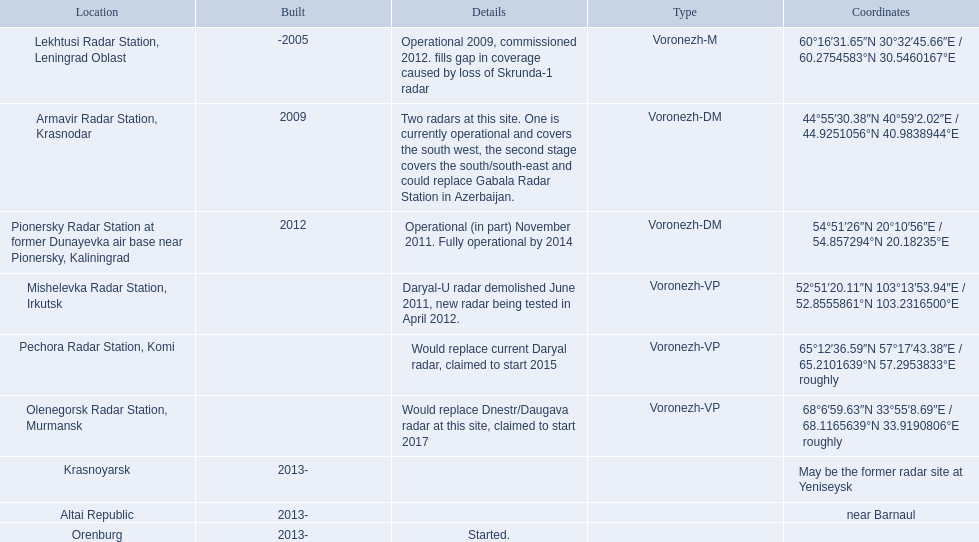Voronezh radar has locations where? Lekhtusi Radar Station, Leningrad Oblast, Armavir Radar Station, Krasnodar, Pionersky Radar Station at former Dunayevka air base near Pionersky, Kaliningrad, Mishelevka Radar Station, Irkutsk, Pechora Radar Station, Komi, Olenegorsk Radar Station, Murmansk, Krasnoyarsk, Altai Republic, Orenburg. Which of these locations have know coordinates? Lekhtusi Radar Station, Leningrad Oblast, Armavir Radar Station, Krasnodar, Pionersky Radar Station at former Dunayevka air base near Pionersky, Kaliningrad, Mishelevka Radar Station, Irkutsk, Pechora Radar Station, Komi, Olenegorsk Radar Station, Murmansk. Which of these locations has coordinates of 60deg16'31.65''n 30deg32'45.66''e / 60.2754583degn 30.5460167dege? Lekhtusi Radar Station, Leningrad Oblast. 